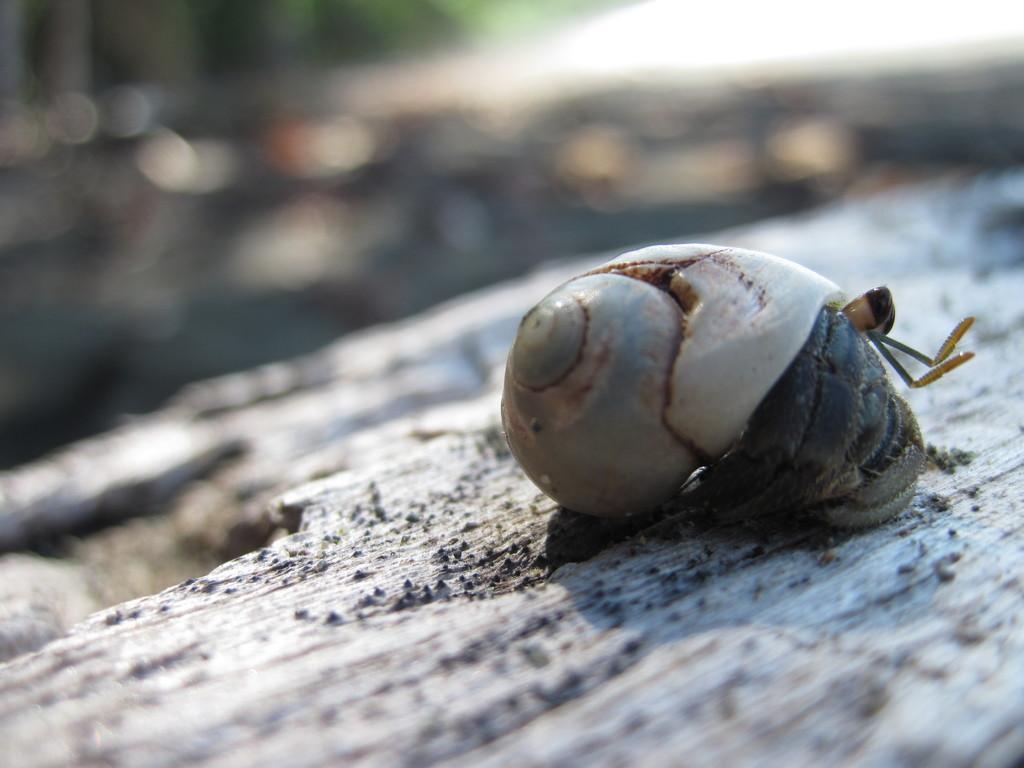Describe this image in one or two sentences. On the right of this picture we can see a snail on an object which seems to be the ground. The background of the image is blurry. 